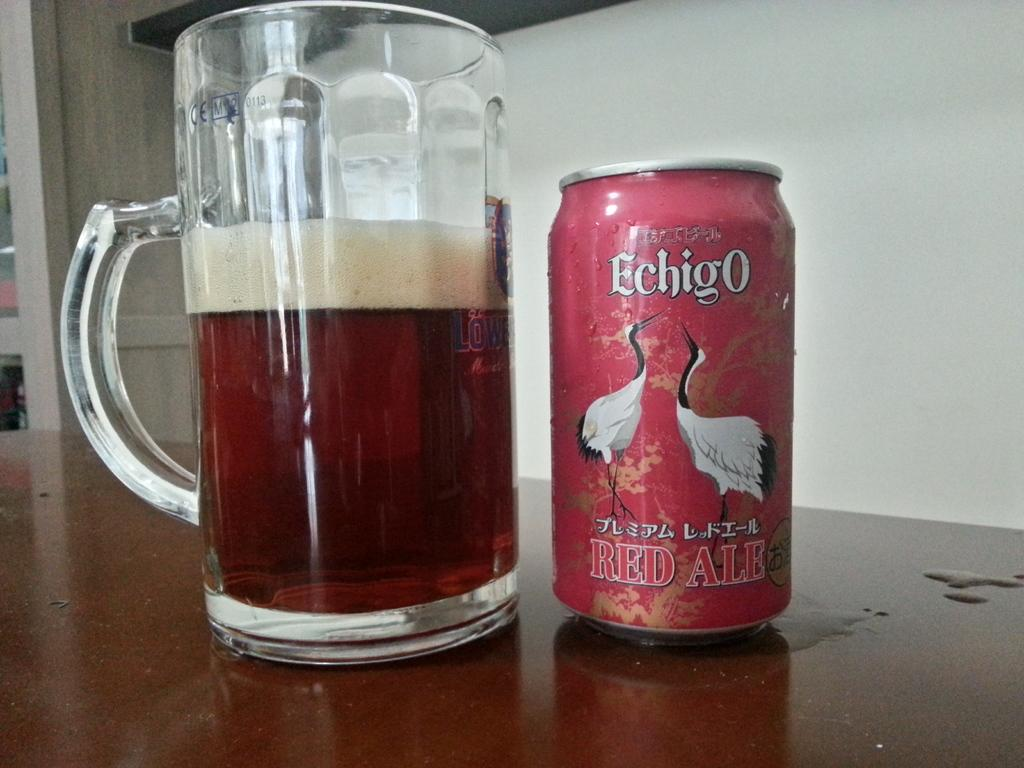<image>
Give a short and clear explanation of the subsequent image. A glass pint glass is half filled with echigo branded red ale with the can next to it. 